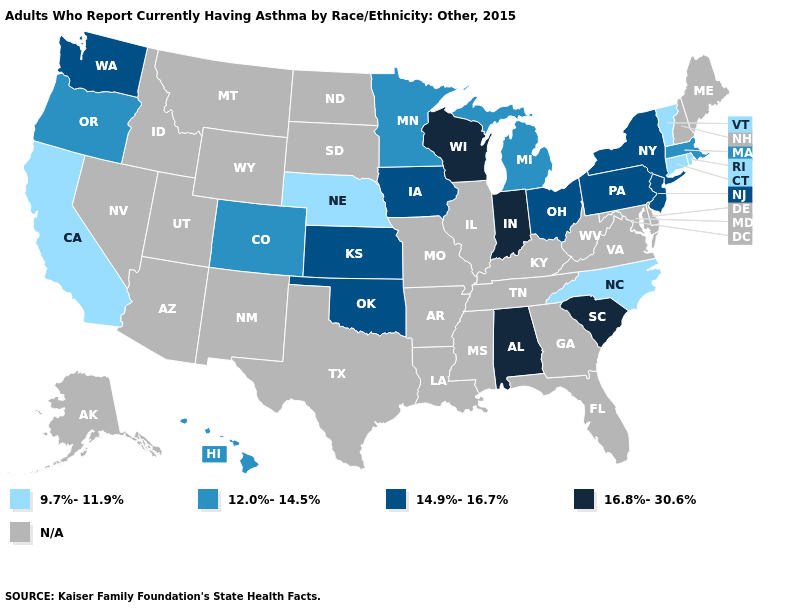How many symbols are there in the legend?
Write a very short answer. 5. Among the states that border Indiana , which have the lowest value?
Write a very short answer. Michigan. What is the value of Connecticut?
Short answer required. 9.7%-11.9%. Does the first symbol in the legend represent the smallest category?
Short answer required. Yes. Does the map have missing data?
Concise answer only. Yes. Does Rhode Island have the lowest value in the Northeast?
Concise answer only. Yes. How many symbols are there in the legend?
Write a very short answer. 5. What is the highest value in the MidWest ?
Concise answer only. 16.8%-30.6%. Name the states that have a value in the range 9.7%-11.9%?
Concise answer only. California, Connecticut, Nebraska, North Carolina, Rhode Island, Vermont. How many symbols are there in the legend?
Write a very short answer. 5. What is the value of Utah?
Answer briefly. N/A. Name the states that have a value in the range 14.9%-16.7%?
Concise answer only. Iowa, Kansas, New Jersey, New York, Ohio, Oklahoma, Pennsylvania, Washington. What is the lowest value in states that border Pennsylvania?
Answer briefly. 14.9%-16.7%. Which states hav the highest value in the Northeast?
Keep it brief. New Jersey, New York, Pennsylvania. 